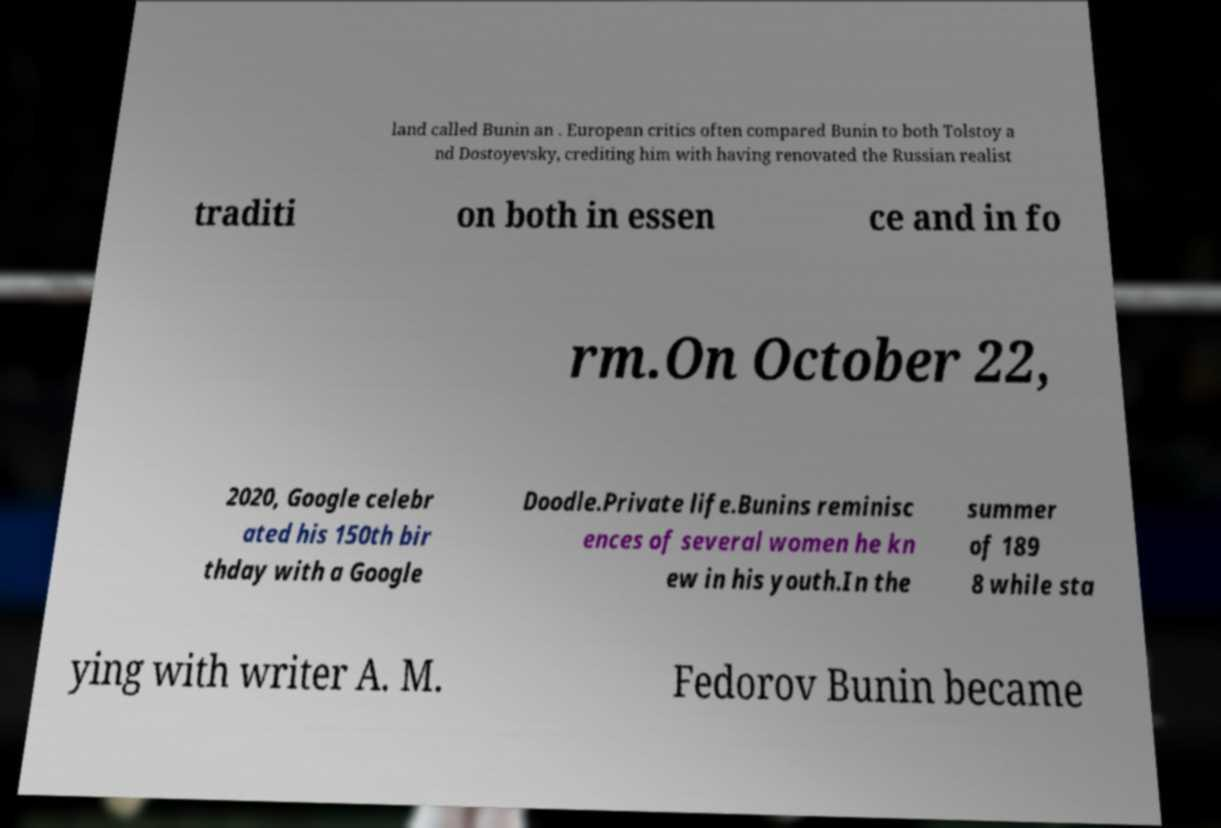Can you accurately transcribe the text from the provided image for me? land called Bunin an . European critics often compared Bunin to both Tolstoy a nd Dostoyevsky, crediting him with having renovated the Russian realist traditi on both in essen ce and in fo rm.On October 22, 2020, Google celebr ated his 150th bir thday with a Google Doodle.Private life.Bunins reminisc ences of several women he kn ew in his youth.In the summer of 189 8 while sta ying with writer A. M. Fedorov Bunin became 